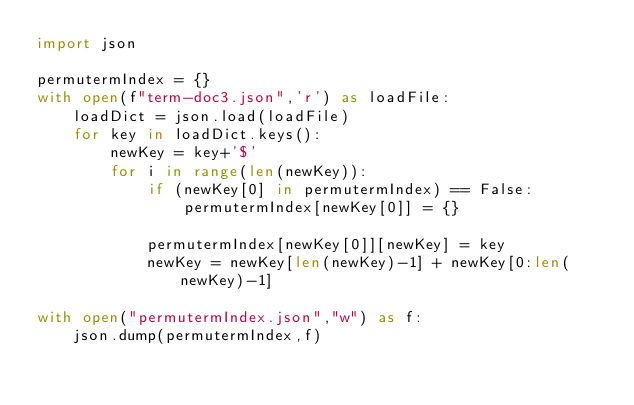Convert code to text. <code><loc_0><loc_0><loc_500><loc_500><_Python_>import json

permutermIndex = {}
with open(f"term-doc3.json",'r') as loadFile:
    loadDict = json.load(loadFile)
    for key in loadDict.keys():
        newKey = key+'$'
        for i in range(len(newKey)):
            if (newKey[0] in permutermIndex) == False:
                permutermIndex[newKey[0]] = {}

            permutermIndex[newKey[0]][newKey] = key
            newKey = newKey[len(newKey)-1] + newKey[0:len(newKey)-1]

with open("permutermIndex.json","w") as f:
    json.dump(permutermIndex,f)
</code> 